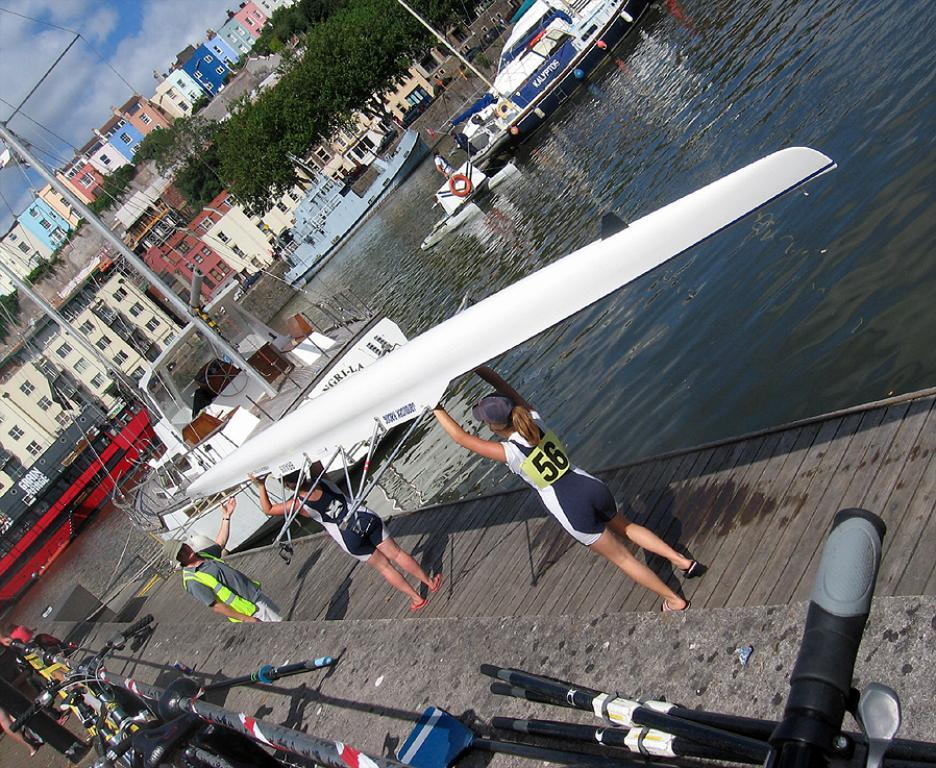Provide a one-sentence caption for the provided image. A woman holding a kayak is wearing a shirt that says 56 on it. 